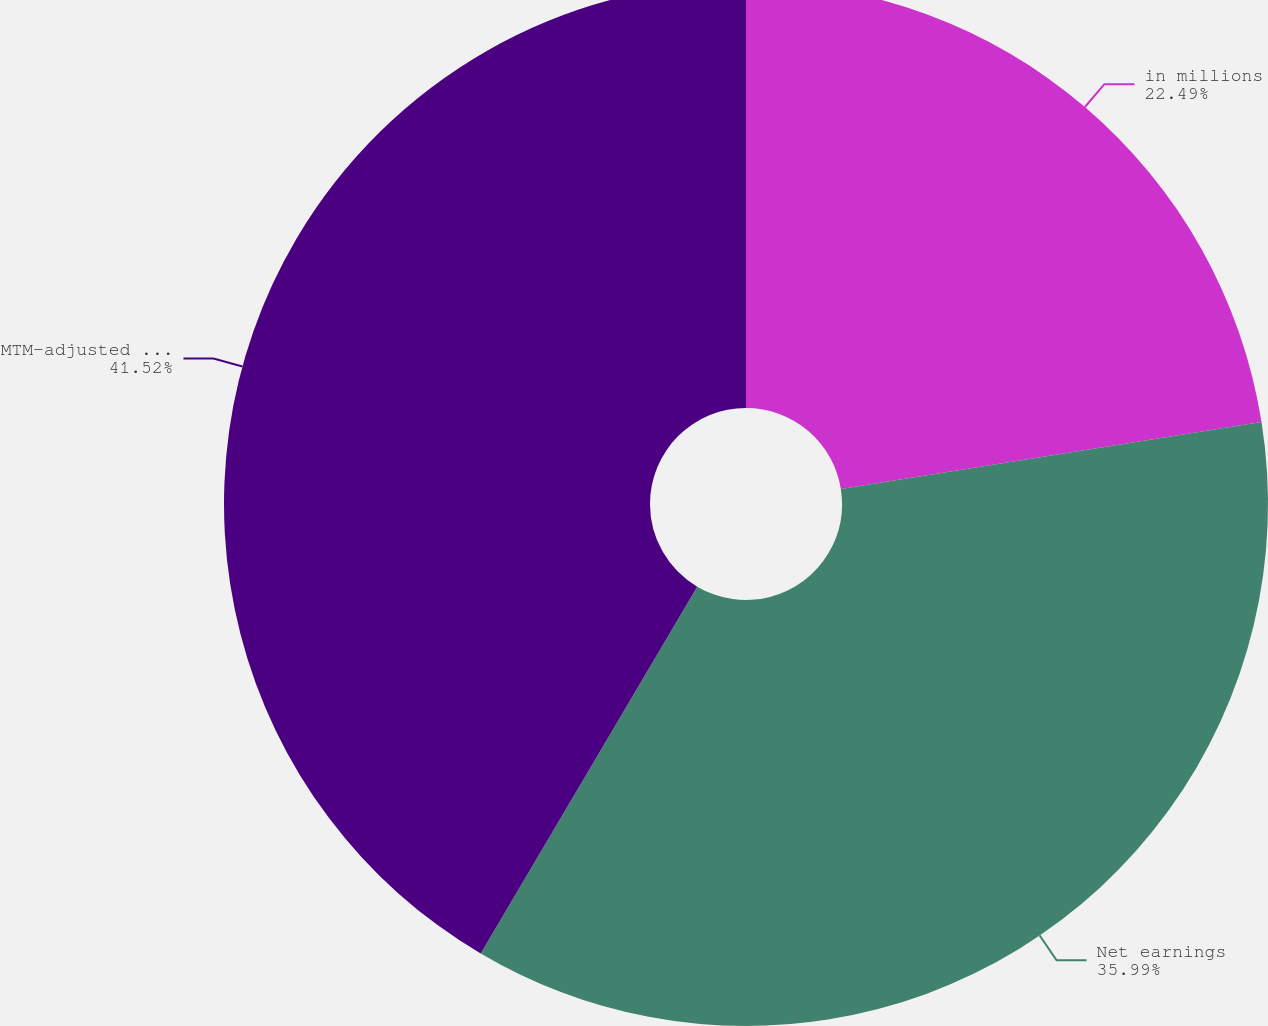Convert chart to OTSL. <chart><loc_0><loc_0><loc_500><loc_500><pie_chart><fcel>in millions<fcel>Net earnings<fcel>MTM-adjusted net earnings<nl><fcel>22.49%<fcel>35.99%<fcel>41.51%<nl></chart> 